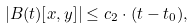Convert formula to latex. <formula><loc_0><loc_0><loc_500><loc_500>\left | B ( t ) [ x , y ] \right | \leq c _ { 2 } \cdot ( t - t _ { 0 } ) ,</formula> 